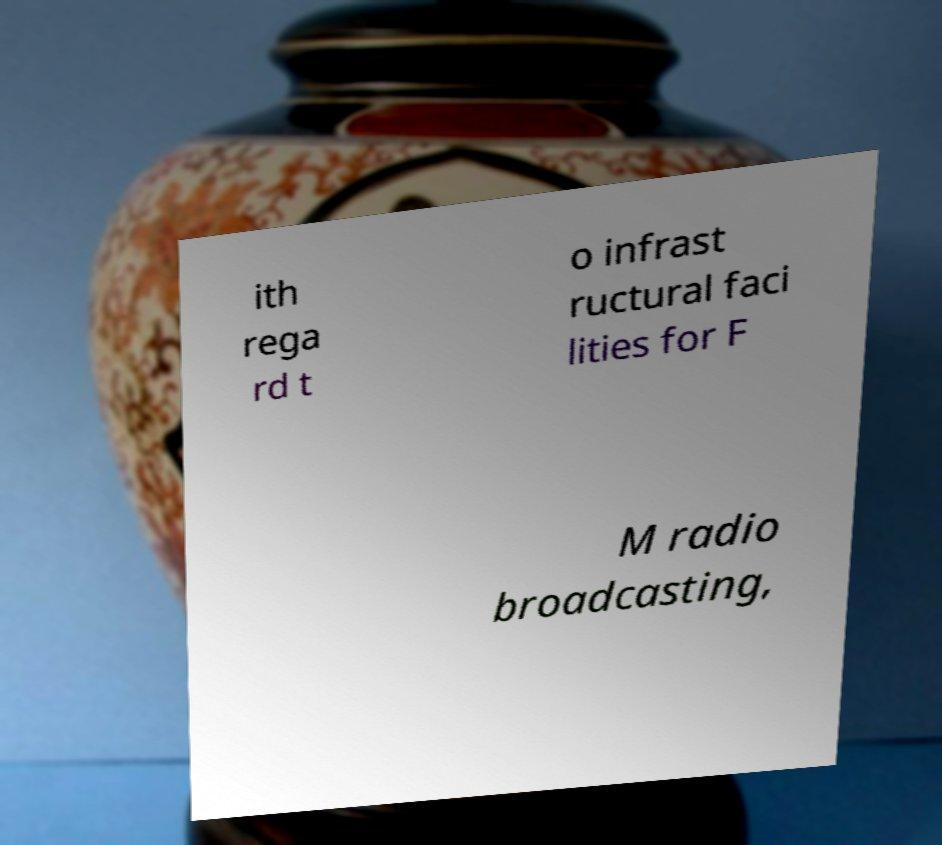Could you extract and type out the text from this image? ith rega rd t o infrast ructural faci lities for F M radio broadcasting, 